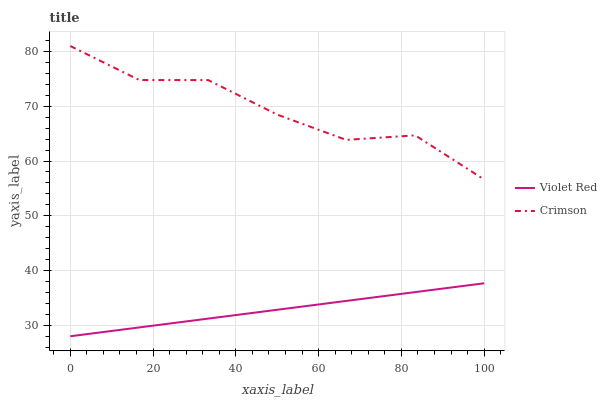Does Violet Red have the minimum area under the curve?
Answer yes or no. Yes. Does Crimson have the maximum area under the curve?
Answer yes or no. Yes. Does Violet Red have the maximum area under the curve?
Answer yes or no. No. Is Violet Red the smoothest?
Answer yes or no. Yes. Is Crimson the roughest?
Answer yes or no. Yes. Is Violet Red the roughest?
Answer yes or no. No. Does Violet Red have the lowest value?
Answer yes or no. Yes. Does Crimson have the highest value?
Answer yes or no. Yes. Does Violet Red have the highest value?
Answer yes or no. No. Is Violet Red less than Crimson?
Answer yes or no. Yes. Is Crimson greater than Violet Red?
Answer yes or no. Yes. Does Violet Red intersect Crimson?
Answer yes or no. No. 